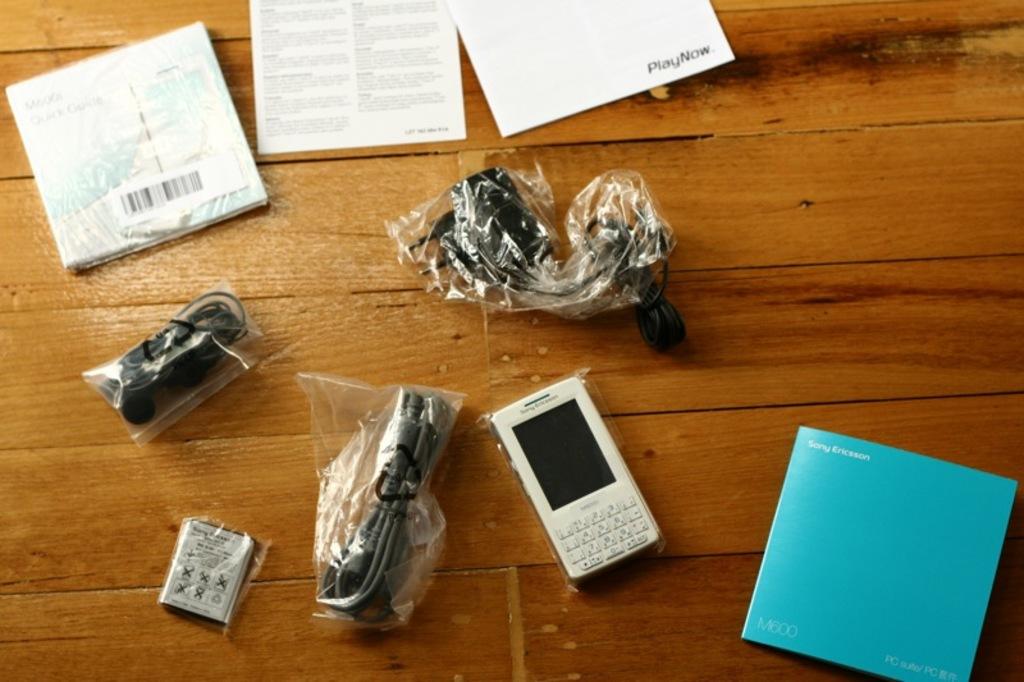What does the booklet at the top right say?
Offer a very short reply. Playnow. 